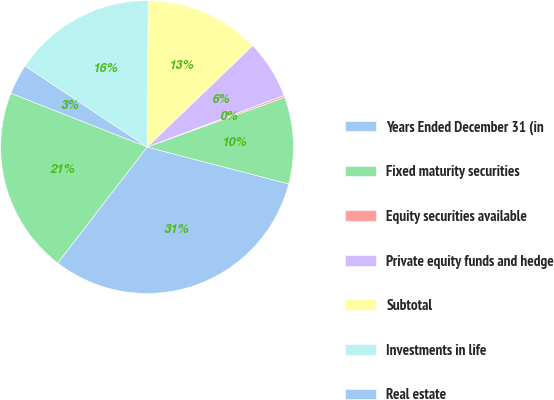Convert chart to OTSL. <chart><loc_0><loc_0><loc_500><loc_500><pie_chart><fcel>Years Ended December 31 (in<fcel>Fixed maturity securities<fcel>Equity securities available<fcel>Private equity funds and hedge<fcel>Subtotal<fcel>Investments in life<fcel>Real estate<fcel>Total<nl><fcel>31.39%<fcel>9.57%<fcel>0.22%<fcel>6.45%<fcel>12.69%<fcel>15.81%<fcel>3.34%<fcel>20.54%<nl></chart> 